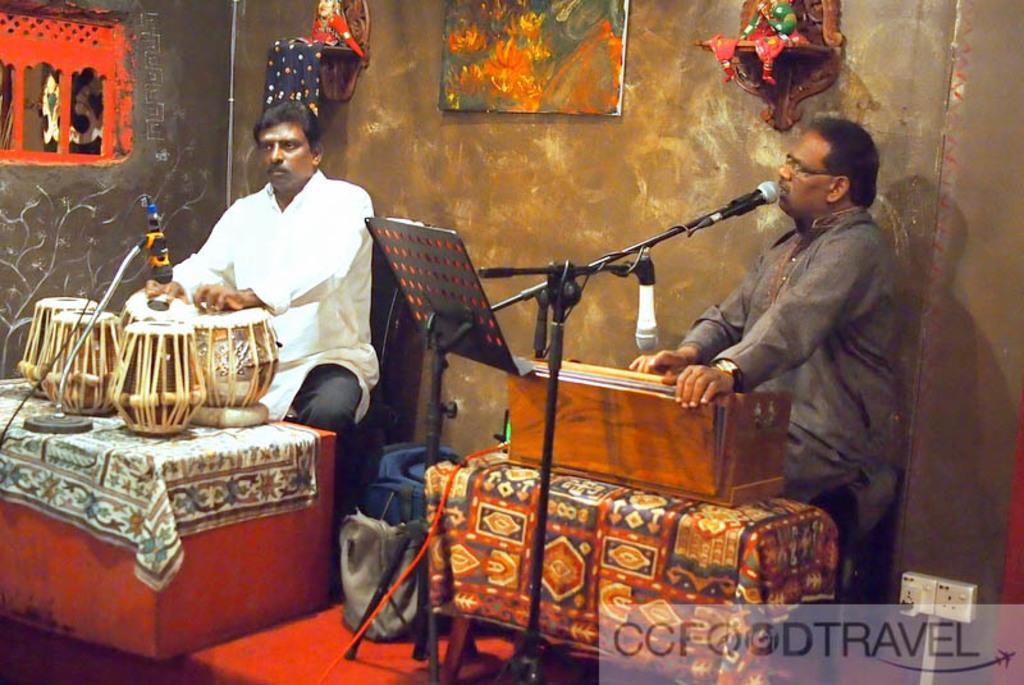Describe this image in one or two sentences. In this picture there is a person who is sitting at the left side of the image, he is playing the tabla and there is a mic in front of them, there is another person at the right side of the image who is playing the harmonium and there is also a mic in front of him, there is a blue color bag on the floor, there is a portrait on the wall and there is a red color window on the wall at the left side of the image, there are two tables in front of them, on which the musical instruments are placed. 